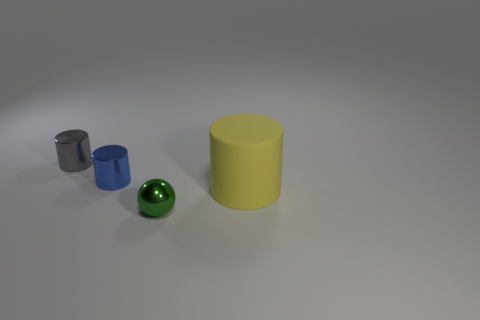What is the material of the blue object that is the same shape as the big yellow rubber thing?
Offer a very short reply. Metal. There is a small green object that is the same material as the tiny blue cylinder; what shape is it?
Offer a terse response. Sphere. There is a metallic cylinder that is right of the gray metallic cylinder; is it the same size as the small gray thing?
Offer a terse response. Yes. What number of things are small shiny things in front of the large cylinder or yellow matte cylinders that are behind the tiny green ball?
Provide a succinct answer. 2. There is a tiny object that is in front of the yellow cylinder; does it have the same color as the rubber cylinder?
Offer a terse response. No. What number of metallic objects are gray cylinders or spheres?
Your response must be concise. 2. There is a small blue object; what shape is it?
Offer a very short reply. Cylinder. Is there any other thing that is made of the same material as the yellow thing?
Keep it short and to the point. No. Does the gray thing have the same material as the ball?
Your answer should be compact. Yes. Is there a blue object in front of the shiny object that is in front of the cylinder that is to the right of the green metal object?
Give a very brief answer. No. 